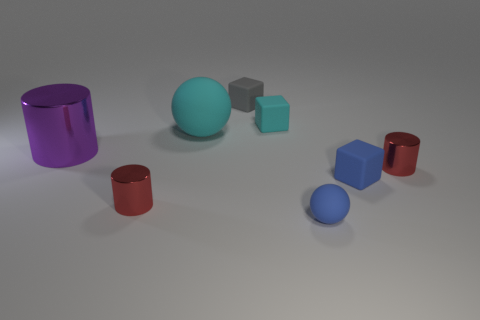What number of other things are the same size as the purple cylinder?
Give a very brief answer. 1. What number of small things are right of the gray object and behind the cyan matte sphere?
Offer a very short reply. 1. Do the ball in front of the purple shiny thing and the red cylinder to the left of the tiny cyan block have the same size?
Offer a very short reply. Yes. What is the size of the rubber sphere on the left side of the blue matte ball?
Your response must be concise. Large. What number of objects are either small rubber cubes that are in front of the purple thing or tiny red things that are left of the small cyan rubber block?
Provide a short and direct response. 2. Is there any other thing of the same color as the large sphere?
Provide a short and direct response. Yes. Are there an equal number of things in front of the large purple shiny object and large rubber things to the right of the cyan block?
Your answer should be compact. No. Is the number of small cyan blocks that are right of the tiny gray thing greater than the number of large yellow metallic cylinders?
Provide a short and direct response. Yes. How many objects are either red metallic cylinders that are on the left side of the tiny gray thing or cylinders?
Provide a short and direct response. 3. What number of red cylinders are made of the same material as the tiny cyan thing?
Keep it short and to the point. 0. 